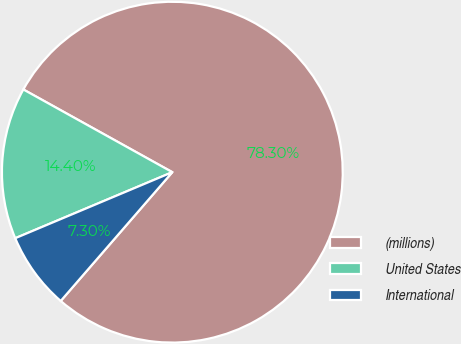<chart> <loc_0><loc_0><loc_500><loc_500><pie_chart><fcel>(millions)<fcel>United States<fcel>International<nl><fcel>78.3%<fcel>14.4%<fcel>7.3%<nl></chart> 